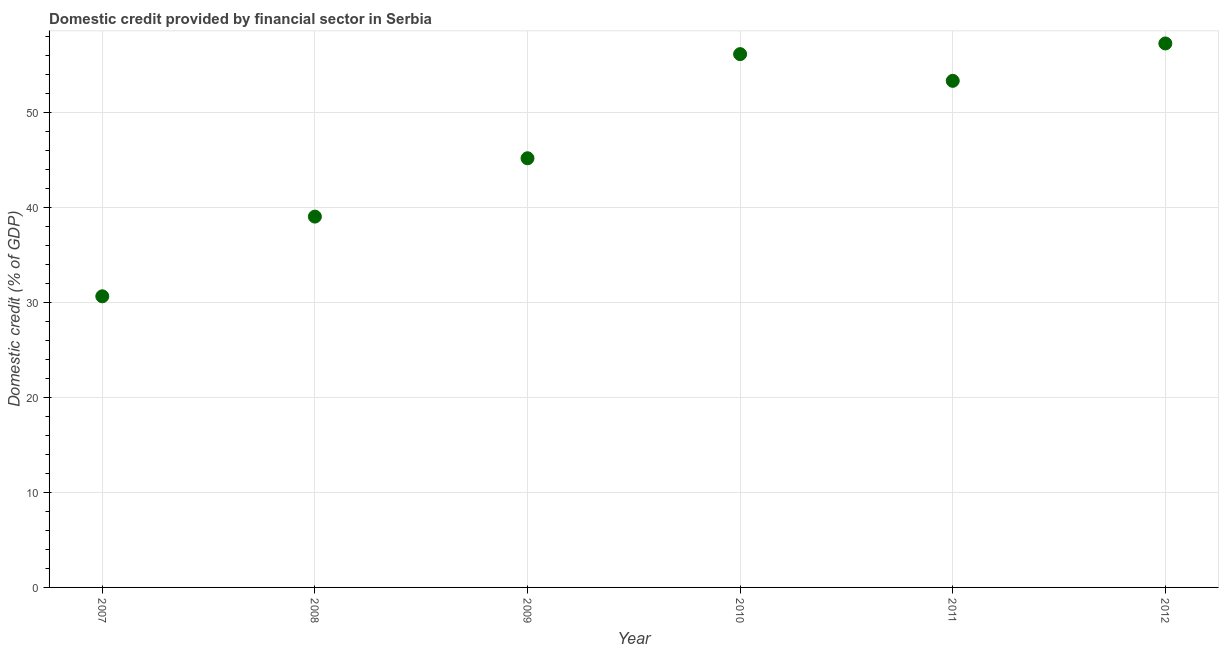What is the domestic credit provided by financial sector in 2012?
Offer a terse response. 57.28. Across all years, what is the maximum domestic credit provided by financial sector?
Give a very brief answer. 57.28. Across all years, what is the minimum domestic credit provided by financial sector?
Your answer should be very brief. 30.66. What is the sum of the domestic credit provided by financial sector?
Your response must be concise. 281.7. What is the difference between the domestic credit provided by financial sector in 2008 and 2009?
Provide a short and direct response. -6.14. What is the average domestic credit provided by financial sector per year?
Provide a short and direct response. 46.95. What is the median domestic credit provided by financial sector?
Offer a terse response. 49.27. In how many years, is the domestic credit provided by financial sector greater than 42 %?
Make the answer very short. 4. What is the ratio of the domestic credit provided by financial sector in 2008 to that in 2012?
Your response must be concise. 0.68. Is the domestic credit provided by financial sector in 2010 less than that in 2012?
Offer a very short reply. Yes. What is the difference between the highest and the second highest domestic credit provided by financial sector?
Your response must be concise. 1.12. Is the sum of the domestic credit provided by financial sector in 2007 and 2009 greater than the maximum domestic credit provided by financial sector across all years?
Your answer should be compact. Yes. What is the difference between the highest and the lowest domestic credit provided by financial sector?
Provide a succinct answer. 26.63. In how many years, is the domestic credit provided by financial sector greater than the average domestic credit provided by financial sector taken over all years?
Your answer should be very brief. 3. How many dotlines are there?
Your response must be concise. 1. How many years are there in the graph?
Offer a terse response. 6. What is the title of the graph?
Give a very brief answer. Domestic credit provided by financial sector in Serbia. What is the label or title of the Y-axis?
Provide a succinct answer. Domestic credit (% of GDP). What is the Domestic credit (% of GDP) in 2007?
Your answer should be very brief. 30.66. What is the Domestic credit (% of GDP) in 2008?
Offer a terse response. 39.05. What is the Domestic credit (% of GDP) in 2009?
Give a very brief answer. 45.2. What is the Domestic credit (% of GDP) in 2010?
Make the answer very short. 56.16. What is the Domestic credit (% of GDP) in 2011?
Keep it short and to the point. 53.35. What is the Domestic credit (% of GDP) in 2012?
Your answer should be very brief. 57.28. What is the difference between the Domestic credit (% of GDP) in 2007 and 2008?
Your answer should be very brief. -8.39. What is the difference between the Domestic credit (% of GDP) in 2007 and 2009?
Make the answer very short. -14.54. What is the difference between the Domestic credit (% of GDP) in 2007 and 2010?
Your response must be concise. -25.5. What is the difference between the Domestic credit (% of GDP) in 2007 and 2011?
Give a very brief answer. -22.69. What is the difference between the Domestic credit (% of GDP) in 2007 and 2012?
Make the answer very short. -26.63. What is the difference between the Domestic credit (% of GDP) in 2008 and 2009?
Give a very brief answer. -6.14. What is the difference between the Domestic credit (% of GDP) in 2008 and 2010?
Offer a very short reply. -17.11. What is the difference between the Domestic credit (% of GDP) in 2008 and 2011?
Your answer should be compact. -14.3. What is the difference between the Domestic credit (% of GDP) in 2008 and 2012?
Make the answer very short. -18.23. What is the difference between the Domestic credit (% of GDP) in 2009 and 2010?
Give a very brief answer. -10.96. What is the difference between the Domestic credit (% of GDP) in 2009 and 2011?
Your answer should be compact. -8.15. What is the difference between the Domestic credit (% of GDP) in 2009 and 2012?
Provide a succinct answer. -12.09. What is the difference between the Domestic credit (% of GDP) in 2010 and 2011?
Keep it short and to the point. 2.81. What is the difference between the Domestic credit (% of GDP) in 2010 and 2012?
Provide a succinct answer. -1.12. What is the difference between the Domestic credit (% of GDP) in 2011 and 2012?
Give a very brief answer. -3.94. What is the ratio of the Domestic credit (% of GDP) in 2007 to that in 2008?
Your response must be concise. 0.79. What is the ratio of the Domestic credit (% of GDP) in 2007 to that in 2009?
Give a very brief answer. 0.68. What is the ratio of the Domestic credit (% of GDP) in 2007 to that in 2010?
Offer a very short reply. 0.55. What is the ratio of the Domestic credit (% of GDP) in 2007 to that in 2011?
Keep it short and to the point. 0.57. What is the ratio of the Domestic credit (% of GDP) in 2007 to that in 2012?
Keep it short and to the point. 0.54. What is the ratio of the Domestic credit (% of GDP) in 2008 to that in 2009?
Provide a succinct answer. 0.86. What is the ratio of the Domestic credit (% of GDP) in 2008 to that in 2010?
Make the answer very short. 0.69. What is the ratio of the Domestic credit (% of GDP) in 2008 to that in 2011?
Provide a succinct answer. 0.73. What is the ratio of the Domestic credit (% of GDP) in 2008 to that in 2012?
Provide a short and direct response. 0.68. What is the ratio of the Domestic credit (% of GDP) in 2009 to that in 2010?
Offer a very short reply. 0.81. What is the ratio of the Domestic credit (% of GDP) in 2009 to that in 2011?
Provide a short and direct response. 0.85. What is the ratio of the Domestic credit (% of GDP) in 2009 to that in 2012?
Keep it short and to the point. 0.79. What is the ratio of the Domestic credit (% of GDP) in 2010 to that in 2011?
Keep it short and to the point. 1.05. What is the ratio of the Domestic credit (% of GDP) in 2010 to that in 2012?
Keep it short and to the point. 0.98. What is the ratio of the Domestic credit (% of GDP) in 2011 to that in 2012?
Ensure brevity in your answer.  0.93. 